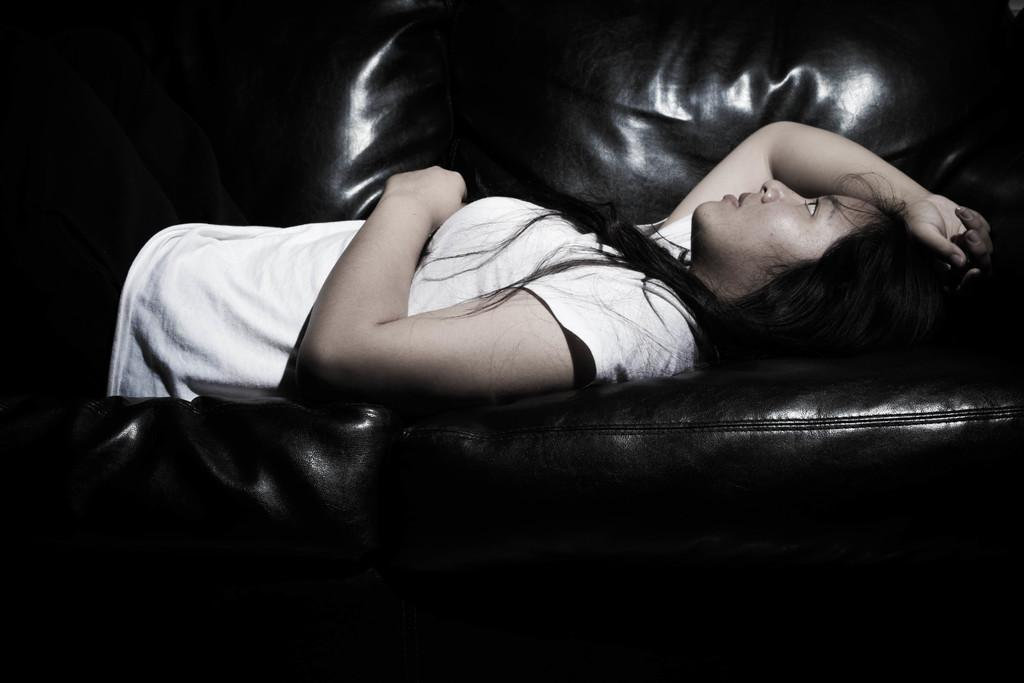What is the main subject of the image? There is a person in the image. What is the person doing in the image? The person is lying on a sofa. What type of pin can be seen holding the person's clothes together in the image? There is no pin visible in the image, and the person's clothes are not mentioned. 